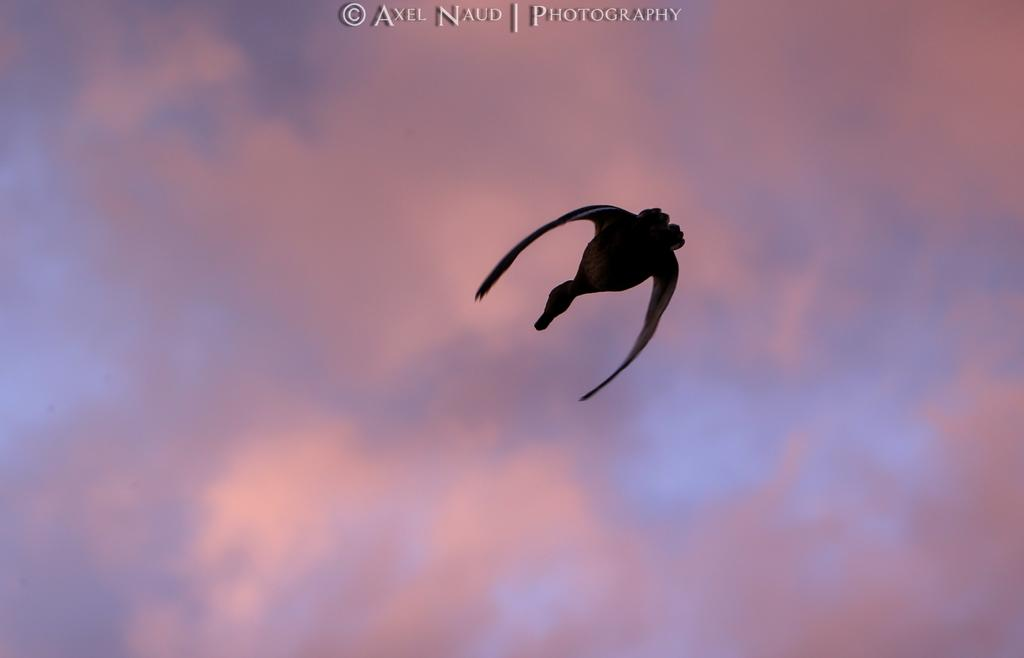What is the main subject of the image? There is a bird in the image. What is the bird doing in the image? The bird is flying in the air. What can be seen in the background of the image? There is a cloudy sky in the background of the image. Is there any additional information about the image? Yes, the image has a watermark. How many grapes can be seen hanging from the bird's beak in the image? There are no grapes present in the image, and the bird's beak is not visible in the image. What type of nose can be seen on the bird in the image? Birds do not have noses like humans; they have a beak, which is visible in the image. However, the specific type of beak cannot be determined from the image. 